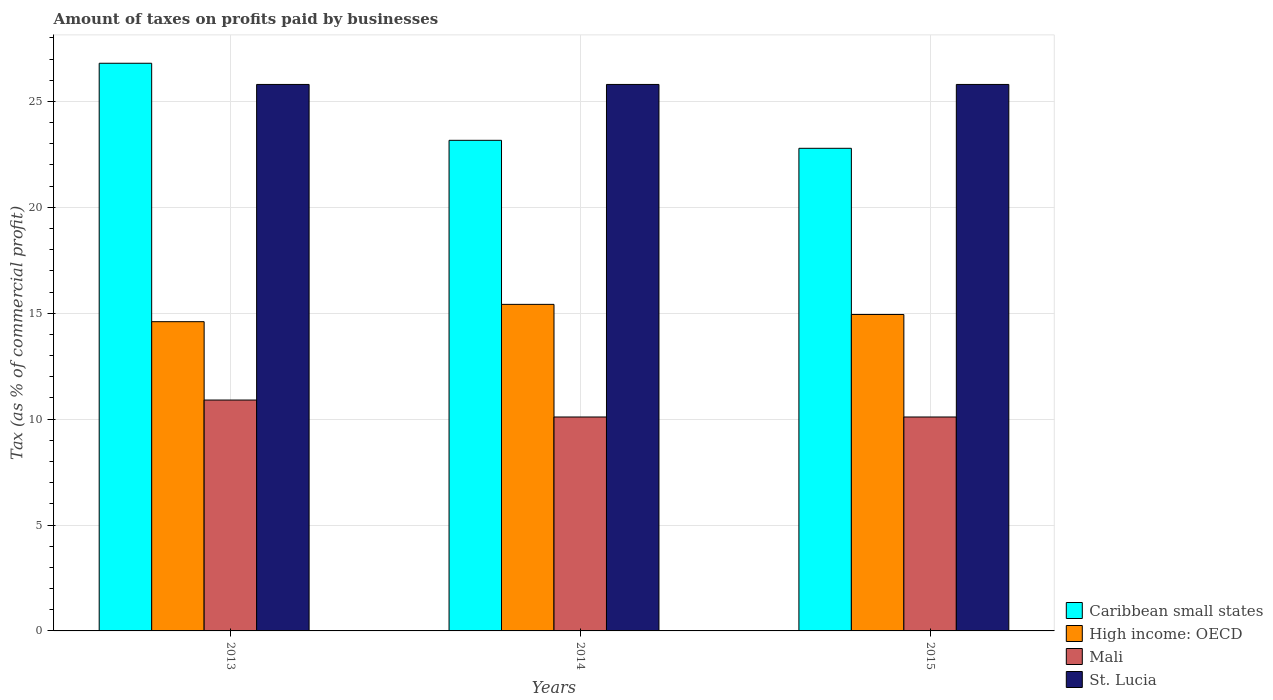How many different coloured bars are there?
Your answer should be compact. 4. How many groups of bars are there?
Your response must be concise. 3. Are the number of bars on each tick of the X-axis equal?
Give a very brief answer. Yes. How many bars are there on the 3rd tick from the left?
Your response must be concise. 4. How many bars are there on the 1st tick from the right?
Provide a succinct answer. 4. What is the percentage of taxes paid by businesses in St. Lucia in 2015?
Offer a terse response. 25.8. In which year was the percentage of taxes paid by businesses in High income: OECD maximum?
Your answer should be compact. 2014. What is the total percentage of taxes paid by businesses in St. Lucia in the graph?
Ensure brevity in your answer.  77.4. What is the difference between the percentage of taxes paid by businesses in Caribbean small states in 2014 and that in 2015?
Offer a terse response. 0.38. What is the difference between the percentage of taxes paid by businesses in High income: OECD in 2014 and the percentage of taxes paid by businesses in Caribbean small states in 2013?
Offer a very short reply. -11.38. What is the average percentage of taxes paid by businesses in St. Lucia per year?
Ensure brevity in your answer.  25.8. In the year 2013, what is the difference between the percentage of taxes paid by businesses in High income: OECD and percentage of taxes paid by businesses in St. Lucia?
Offer a very short reply. -11.2. What is the ratio of the percentage of taxes paid by businesses in St. Lucia in 2013 to that in 2014?
Provide a succinct answer. 1. Is the percentage of taxes paid by businesses in Caribbean small states in 2013 less than that in 2014?
Provide a succinct answer. No. Is the difference between the percentage of taxes paid by businesses in High income: OECD in 2013 and 2014 greater than the difference between the percentage of taxes paid by businesses in St. Lucia in 2013 and 2014?
Your answer should be very brief. No. What is the difference between the highest and the second highest percentage of taxes paid by businesses in Mali?
Your answer should be very brief. 0.8. What is the difference between the highest and the lowest percentage of taxes paid by businesses in St. Lucia?
Offer a very short reply. 0. What does the 4th bar from the left in 2013 represents?
Provide a succinct answer. St. Lucia. What does the 1st bar from the right in 2014 represents?
Make the answer very short. St. Lucia. Is it the case that in every year, the sum of the percentage of taxes paid by businesses in High income: OECD and percentage of taxes paid by businesses in Caribbean small states is greater than the percentage of taxes paid by businesses in St. Lucia?
Offer a very short reply. Yes. What is the difference between two consecutive major ticks on the Y-axis?
Offer a very short reply. 5. Are the values on the major ticks of Y-axis written in scientific E-notation?
Give a very brief answer. No. Does the graph contain grids?
Your answer should be compact. Yes. How many legend labels are there?
Keep it short and to the point. 4. How are the legend labels stacked?
Your answer should be very brief. Vertical. What is the title of the graph?
Provide a succinct answer. Amount of taxes on profits paid by businesses. Does "Bulgaria" appear as one of the legend labels in the graph?
Your answer should be very brief. No. What is the label or title of the Y-axis?
Ensure brevity in your answer.  Tax (as % of commercial profit). What is the Tax (as % of commercial profit) of Caribbean small states in 2013?
Provide a succinct answer. 26.8. What is the Tax (as % of commercial profit) in Mali in 2013?
Offer a terse response. 10.9. What is the Tax (as % of commercial profit) of St. Lucia in 2013?
Make the answer very short. 25.8. What is the Tax (as % of commercial profit) in Caribbean small states in 2014?
Your response must be concise. 23.16. What is the Tax (as % of commercial profit) of High income: OECD in 2014?
Your answer should be compact. 15.42. What is the Tax (as % of commercial profit) of Mali in 2014?
Ensure brevity in your answer.  10.1. What is the Tax (as % of commercial profit) in St. Lucia in 2014?
Provide a succinct answer. 25.8. What is the Tax (as % of commercial profit) in Caribbean small states in 2015?
Your answer should be very brief. 22.78. What is the Tax (as % of commercial profit) in High income: OECD in 2015?
Keep it short and to the point. 14.94. What is the Tax (as % of commercial profit) in St. Lucia in 2015?
Provide a succinct answer. 25.8. Across all years, what is the maximum Tax (as % of commercial profit) in Caribbean small states?
Keep it short and to the point. 26.8. Across all years, what is the maximum Tax (as % of commercial profit) in High income: OECD?
Your answer should be compact. 15.42. Across all years, what is the maximum Tax (as % of commercial profit) in Mali?
Ensure brevity in your answer.  10.9. Across all years, what is the maximum Tax (as % of commercial profit) in St. Lucia?
Your answer should be very brief. 25.8. Across all years, what is the minimum Tax (as % of commercial profit) in Caribbean small states?
Your answer should be compact. 22.78. Across all years, what is the minimum Tax (as % of commercial profit) in High income: OECD?
Provide a short and direct response. 14.6. Across all years, what is the minimum Tax (as % of commercial profit) in St. Lucia?
Offer a terse response. 25.8. What is the total Tax (as % of commercial profit) in Caribbean small states in the graph?
Your answer should be compact. 72.75. What is the total Tax (as % of commercial profit) of High income: OECD in the graph?
Your answer should be compact. 44.96. What is the total Tax (as % of commercial profit) in Mali in the graph?
Your response must be concise. 31.1. What is the total Tax (as % of commercial profit) of St. Lucia in the graph?
Provide a succinct answer. 77.4. What is the difference between the Tax (as % of commercial profit) in Caribbean small states in 2013 and that in 2014?
Keep it short and to the point. 3.64. What is the difference between the Tax (as % of commercial profit) in High income: OECD in 2013 and that in 2014?
Your answer should be compact. -0.82. What is the difference between the Tax (as % of commercial profit) of Mali in 2013 and that in 2014?
Ensure brevity in your answer.  0.8. What is the difference between the Tax (as % of commercial profit) of Caribbean small states in 2013 and that in 2015?
Provide a succinct answer. 4.02. What is the difference between the Tax (as % of commercial profit) in High income: OECD in 2013 and that in 2015?
Ensure brevity in your answer.  -0.34. What is the difference between the Tax (as % of commercial profit) of Caribbean small states in 2014 and that in 2015?
Provide a short and direct response. 0.38. What is the difference between the Tax (as % of commercial profit) in High income: OECD in 2014 and that in 2015?
Offer a very short reply. 0.48. What is the difference between the Tax (as % of commercial profit) in Mali in 2014 and that in 2015?
Your answer should be very brief. 0. What is the difference between the Tax (as % of commercial profit) in Caribbean small states in 2013 and the Tax (as % of commercial profit) in High income: OECD in 2014?
Your answer should be compact. 11.38. What is the difference between the Tax (as % of commercial profit) in Caribbean small states in 2013 and the Tax (as % of commercial profit) in Mali in 2014?
Offer a terse response. 16.7. What is the difference between the Tax (as % of commercial profit) of High income: OECD in 2013 and the Tax (as % of commercial profit) of Mali in 2014?
Ensure brevity in your answer.  4.5. What is the difference between the Tax (as % of commercial profit) in Mali in 2013 and the Tax (as % of commercial profit) in St. Lucia in 2014?
Your answer should be compact. -14.9. What is the difference between the Tax (as % of commercial profit) in Caribbean small states in 2013 and the Tax (as % of commercial profit) in High income: OECD in 2015?
Give a very brief answer. 11.86. What is the difference between the Tax (as % of commercial profit) of Caribbean small states in 2013 and the Tax (as % of commercial profit) of Mali in 2015?
Give a very brief answer. 16.7. What is the difference between the Tax (as % of commercial profit) in High income: OECD in 2013 and the Tax (as % of commercial profit) in Mali in 2015?
Ensure brevity in your answer.  4.5. What is the difference between the Tax (as % of commercial profit) of Mali in 2013 and the Tax (as % of commercial profit) of St. Lucia in 2015?
Make the answer very short. -14.9. What is the difference between the Tax (as % of commercial profit) in Caribbean small states in 2014 and the Tax (as % of commercial profit) in High income: OECD in 2015?
Your response must be concise. 8.22. What is the difference between the Tax (as % of commercial profit) in Caribbean small states in 2014 and the Tax (as % of commercial profit) in Mali in 2015?
Give a very brief answer. 13.06. What is the difference between the Tax (as % of commercial profit) of Caribbean small states in 2014 and the Tax (as % of commercial profit) of St. Lucia in 2015?
Your response must be concise. -2.64. What is the difference between the Tax (as % of commercial profit) in High income: OECD in 2014 and the Tax (as % of commercial profit) in Mali in 2015?
Offer a terse response. 5.32. What is the difference between the Tax (as % of commercial profit) in High income: OECD in 2014 and the Tax (as % of commercial profit) in St. Lucia in 2015?
Offer a very short reply. -10.38. What is the difference between the Tax (as % of commercial profit) in Mali in 2014 and the Tax (as % of commercial profit) in St. Lucia in 2015?
Make the answer very short. -15.7. What is the average Tax (as % of commercial profit) of Caribbean small states per year?
Give a very brief answer. 24.25. What is the average Tax (as % of commercial profit) of High income: OECD per year?
Your answer should be very brief. 14.99. What is the average Tax (as % of commercial profit) in Mali per year?
Give a very brief answer. 10.37. What is the average Tax (as % of commercial profit) in St. Lucia per year?
Ensure brevity in your answer.  25.8. In the year 2013, what is the difference between the Tax (as % of commercial profit) of Caribbean small states and Tax (as % of commercial profit) of High income: OECD?
Provide a short and direct response. 12.2. In the year 2013, what is the difference between the Tax (as % of commercial profit) in Caribbean small states and Tax (as % of commercial profit) in St. Lucia?
Make the answer very short. 1. In the year 2013, what is the difference between the Tax (as % of commercial profit) of High income: OECD and Tax (as % of commercial profit) of St. Lucia?
Provide a succinct answer. -11.2. In the year 2013, what is the difference between the Tax (as % of commercial profit) of Mali and Tax (as % of commercial profit) of St. Lucia?
Offer a very short reply. -14.9. In the year 2014, what is the difference between the Tax (as % of commercial profit) in Caribbean small states and Tax (as % of commercial profit) in High income: OECD?
Give a very brief answer. 7.74. In the year 2014, what is the difference between the Tax (as % of commercial profit) of Caribbean small states and Tax (as % of commercial profit) of Mali?
Offer a very short reply. 13.06. In the year 2014, what is the difference between the Tax (as % of commercial profit) in Caribbean small states and Tax (as % of commercial profit) in St. Lucia?
Ensure brevity in your answer.  -2.64. In the year 2014, what is the difference between the Tax (as % of commercial profit) of High income: OECD and Tax (as % of commercial profit) of Mali?
Offer a terse response. 5.32. In the year 2014, what is the difference between the Tax (as % of commercial profit) in High income: OECD and Tax (as % of commercial profit) in St. Lucia?
Provide a succinct answer. -10.38. In the year 2014, what is the difference between the Tax (as % of commercial profit) of Mali and Tax (as % of commercial profit) of St. Lucia?
Ensure brevity in your answer.  -15.7. In the year 2015, what is the difference between the Tax (as % of commercial profit) of Caribbean small states and Tax (as % of commercial profit) of High income: OECD?
Provide a succinct answer. 7.84. In the year 2015, what is the difference between the Tax (as % of commercial profit) of Caribbean small states and Tax (as % of commercial profit) of Mali?
Provide a short and direct response. 12.68. In the year 2015, what is the difference between the Tax (as % of commercial profit) of Caribbean small states and Tax (as % of commercial profit) of St. Lucia?
Provide a succinct answer. -3.02. In the year 2015, what is the difference between the Tax (as % of commercial profit) in High income: OECD and Tax (as % of commercial profit) in Mali?
Your response must be concise. 4.84. In the year 2015, what is the difference between the Tax (as % of commercial profit) in High income: OECD and Tax (as % of commercial profit) in St. Lucia?
Provide a succinct answer. -10.86. In the year 2015, what is the difference between the Tax (as % of commercial profit) of Mali and Tax (as % of commercial profit) of St. Lucia?
Provide a short and direct response. -15.7. What is the ratio of the Tax (as % of commercial profit) of Caribbean small states in 2013 to that in 2014?
Provide a short and direct response. 1.16. What is the ratio of the Tax (as % of commercial profit) in High income: OECD in 2013 to that in 2014?
Your response must be concise. 0.95. What is the ratio of the Tax (as % of commercial profit) of Mali in 2013 to that in 2014?
Keep it short and to the point. 1.08. What is the ratio of the Tax (as % of commercial profit) in St. Lucia in 2013 to that in 2014?
Make the answer very short. 1. What is the ratio of the Tax (as % of commercial profit) in Caribbean small states in 2013 to that in 2015?
Offer a terse response. 1.18. What is the ratio of the Tax (as % of commercial profit) in High income: OECD in 2013 to that in 2015?
Your response must be concise. 0.98. What is the ratio of the Tax (as % of commercial profit) of Mali in 2013 to that in 2015?
Give a very brief answer. 1.08. What is the ratio of the Tax (as % of commercial profit) of St. Lucia in 2013 to that in 2015?
Make the answer very short. 1. What is the ratio of the Tax (as % of commercial profit) in Caribbean small states in 2014 to that in 2015?
Provide a succinct answer. 1.02. What is the ratio of the Tax (as % of commercial profit) in High income: OECD in 2014 to that in 2015?
Ensure brevity in your answer.  1.03. What is the difference between the highest and the second highest Tax (as % of commercial profit) of Caribbean small states?
Offer a terse response. 3.64. What is the difference between the highest and the second highest Tax (as % of commercial profit) in High income: OECD?
Provide a short and direct response. 0.48. What is the difference between the highest and the second highest Tax (as % of commercial profit) in Mali?
Your answer should be compact. 0.8. What is the difference between the highest and the lowest Tax (as % of commercial profit) of Caribbean small states?
Offer a terse response. 4.02. What is the difference between the highest and the lowest Tax (as % of commercial profit) in High income: OECD?
Provide a succinct answer. 0.82. What is the difference between the highest and the lowest Tax (as % of commercial profit) in Mali?
Keep it short and to the point. 0.8. What is the difference between the highest and the lowest Tax (as % of commercial profit) of St. Lucia?
Provide a short and direct response. 0. 